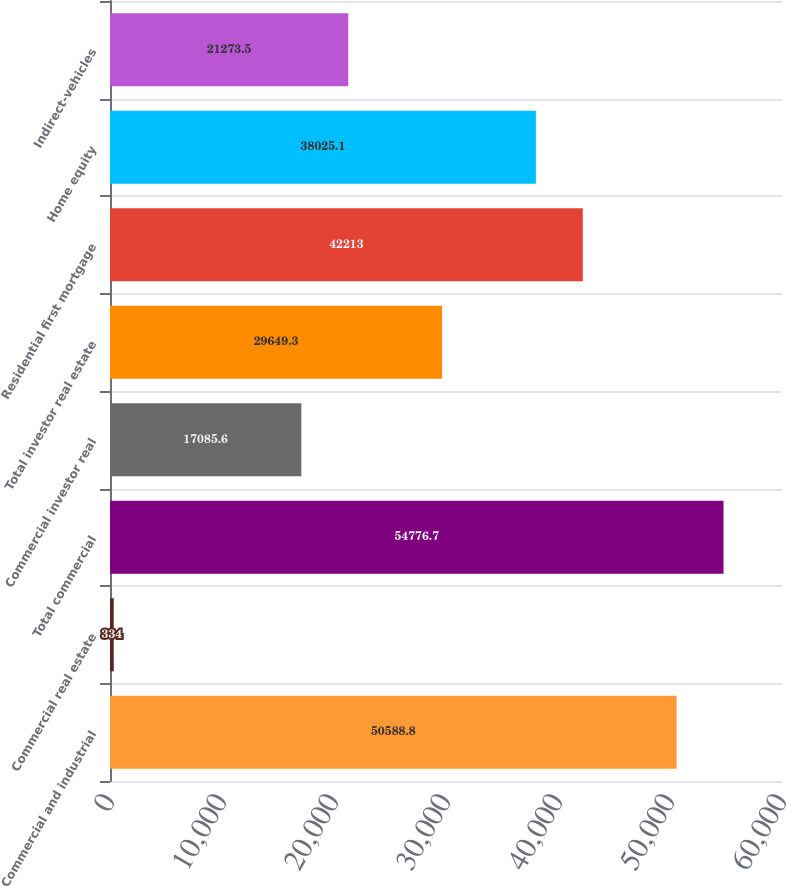<chart> <loc_0><loc_0><loc_500><loc_500><bar_chart><fcel>Commercial and industrial<fcel>Commercial real estate<fcel>Total commercial<fcel>Commercial investor real<fcel>Total investor real estate<fcel>Residential first mortgage<fcel>Home equity<fcel>Indirect-vehicles<nl><fcel>50588.8<fcel>334<fcel>54776.7<fcel>17085.6<fcel>29649.3<fcel>42213<fcel>38025.1<fcel>21273.5<nl></chart> 